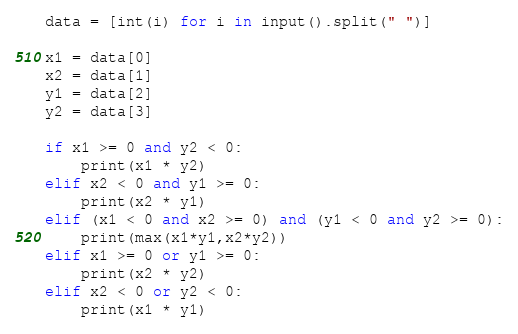<code> <loc_0><loc_0><loc_500><loc_500><_Python_>data = [int(i) for i in input().split(" ")]

x1 = data[0]
x2 = data[1]
y1 = data[2]
y2 = data[3]

if x1 >= 0 and y2 < 0:
    print(x1 * y2)
elif x2 < 0 and y1 >= 0:
    print(x2 * y1)
elif (x1 < 0 and x2 >= 0) and (y1 < 0 and y2 >= 0):
    print(max(x1*y1,x2*y2))
elif x1 >= 0 or y1 >= 0:
    print(x2 * y2)
elif x2 < 0 or y2 < 0:
    print(x1 * y1)
</code> 